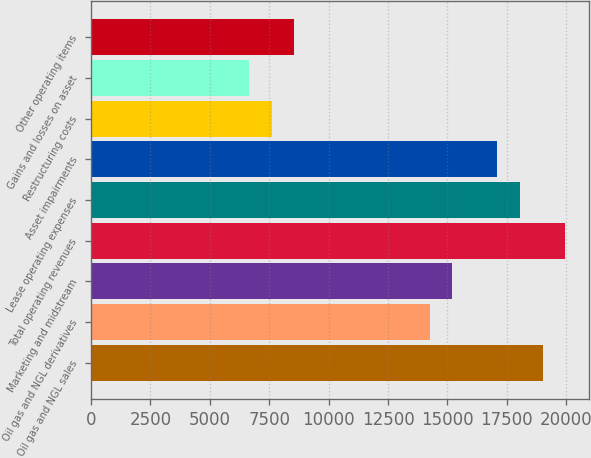<chart> <loc_0><loc_0><loc_500><loc_500><bar_chart><fcel>Oil gas and NGL sales<fcel>Oil gas and NGL derivatives<fcel>Marketing and midstream<fcel>Total operating revenues<fcel>Lease operating expenses<fcel>Asset impairments<fcel>Restructuring costs<fcel>Gains and losses on asset<fcel>Other operating items<nl><fcel>19001.5<fcel>14251.2<fcel>15201.3<fcel>19951.5<fcel>18051.4<fcel>17101.4<fcel>7600.87<fcel>6650.82<fcel>8550.92<nl></chart> 